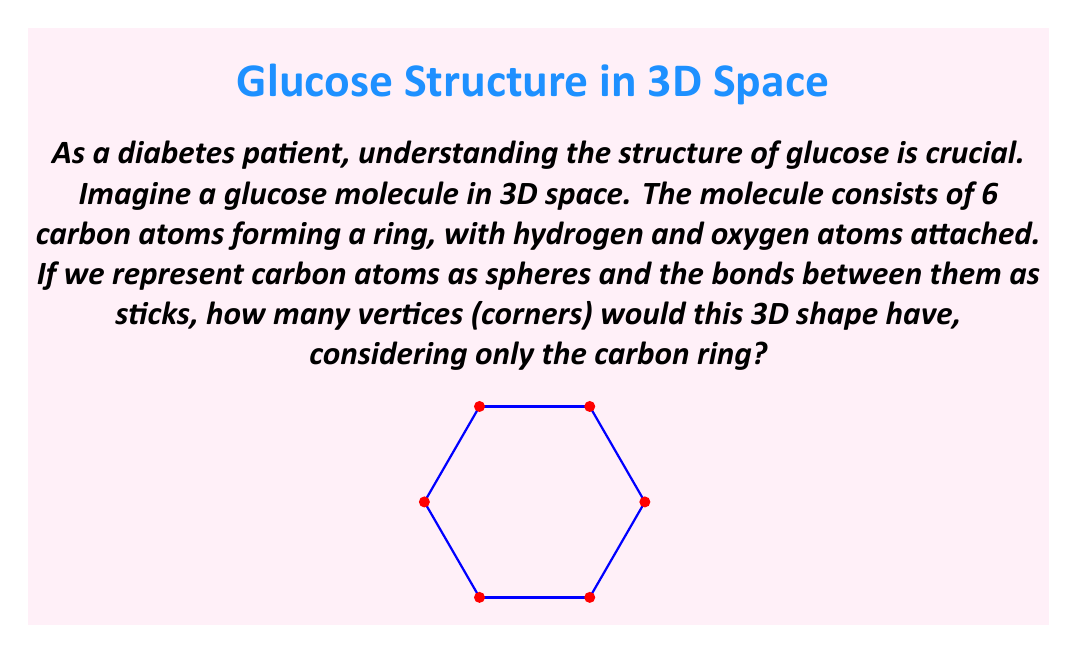Can you answer this question? To solve this problem, let's break it down step-by-step:

1) First, we need to understand what the question is asking. We're focusing only on the carbon ring of the glucose molecule, not the attached hydrogen and oxygen atoms.

2) In a glucose molecule, the 6 carbon atoms form a ring structure. This is often represented as a hexagon in 2D, but in 3D space, it's not perfectly flat.

3) In 3D space, this ring takes on a shape called a "chair conformation." This is because some of the carbon atoms are slightly above or below the plane of the others, making it look a bit like a chair from the side.

4) Despite this 3D arrangement, each carbon atom is still connected to two other carbon atoms in the ring.

5) In geometry, the points where lines (or in this case, bonds) meet are called vertices.

6) Since there are 6 carbon atoms, and each one represents a point where bonds meet, there are 6 vertices in this 3D shape.

7) It's important to note that while the actual glucose molecule has more atoms attached to these carbons, we're only considering the carbon ring for this question.

Therefore, the 3D shape representing the carbon ring of a glucose molecule has 6 vertices.
Answer: 6 vertices 